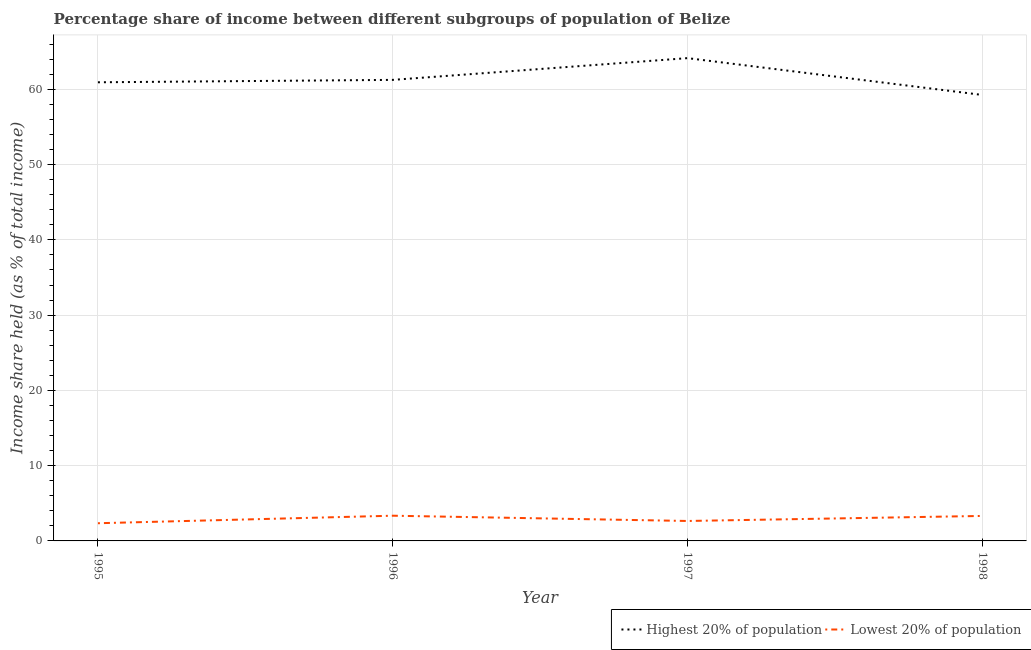Does the line corresponding to income share held by highest 20% of the population intersect with the line corresponding to income share held by lowest 20% of the population?
Your answer should be very brief. No. What is the income share held by highest 20% of the population in 1995?
Make the answer very short. 60.94. Across all years, what is the maximum income share held by lowest 20% of the population?
Provide a succinct answer. 3.35. Across all years, what is the minimum income share held by highest 20% of the population?
Offer a terse response. 59.26. In which year was the income share held by highest 20% of the population maximum?
Ensure brevity in your answer.  1997. In which year was the income share held by highest 20% of the population minimum?
Provide a succinct answer. 1998. What is the total income share held by highest 20% of the population in the graph?
Give a very brief answer. 245.61. What is the difference between the income share held by highest 20% of the population in 1995 and that in 1998?
Offer a very short reply. 1.68. What is the difference between the income share held by highest 20% of the population in 1997 and the income share held by lowest 20% of the population in 1995?
Provide a succinct answer. 61.8. What is the average income share held by highest 20% of the population per year?
Offer a very short reply. 61.4. In the year 1998, what is the difference between the income share held by highest 20% of the population and income share held by lowest 20% of the population?
Ensure brevity in your answer.  55.94. In how many years, is the income share held by lowest 20% of the population greater than 20 %?
Your response must be concise. 0. What is the ratio of the income share held by highest 20% of the population in 1995 to that in 1996?
Your response must be concise. 0.99. Is the income share held by lowest 20% of the population in 1996 less than that in 1998?
Provide a succinct answer. No. Is the difference between the income share held by highest 20% of the population in 1996 and 1998 greater than the difference between the income share held by lowest 20% of the population in 1996 and 1998?
Give a very brief answer. Yes. What is the difference between the highest and the second highest income share held by highest 20% of the population?
Your answer should be compact. 2.89. What is the difference between the highest and the lowest income share held by highest 20% of the population?
Offer a very short reply. 4.89. In how many years, is the income share held by highest 20% of the population greater than the average income share held by highest 20% of the population taken over all years?
Keep it short and to the point. 1. Does the income share held by lowest 20% of the population monotonically increase over the years?
Your answer should be compact. No. Is the income share held by highest 20% of the population strictly greater than the income share held by lowest 20% of the population over the years?
Offer a very short reply. Yes. Is the income share held by highest 20% of the population strictly less than the income share held by lowest 20% of the population over the years?
Offer a terse response. No. What is the difference between two consecutive major ticks on the Y-axis?
Give a very brief answer. 10. Does the graph contain grids?
Your answer should be compact. Yes. Where does the legend appear in the graph?
Provide a short and direct response. Bottom right. How are the legend labels stacked?
Provide a short and direct response. Horizontal. What is the title of the graph?
Offer a terse response. Percentage share of income between different subgroups of population of Belize. Does "All education staff compensation" appear as one of the legend labels in the graph?
Provide a short and direct response. No. What is the label or title of the X-axis?
Your answer should be compact. Year. What is the label or title of the Y-axis?
Make the answer very short. Income share held (as % of total income). What is the Income share held (as % of total income) in Highest 20% of population in 1995?
Your answer should be compact. 60.94. What is the Income share held (as % of total income) of Lowest 20% of population in 1995?
Ensure brevity in your answer.  2.35. What is the Income share held (as % of total income) in Highest 20% of population in 1996?
Make the answer very short. 61.26. What is the Income share held (as % of total income) of Lowest 20% of population in 1996?
Give a very brief answer. 3.35. What is the Income share held (as % of total income) in Highest 20% of population in 1997?
Offer a terse response. 64.15. What is the Income share held (as % of total income) in Lowest 20% of population in 1997?
Your answer should be very brief. 2.65. What is the Income share held (as % of total income) in Highest 20% of population in 1998?
Your answer should be compact. 59.26. What is the Income share held (as % of total income) in Lowest 20% of population in 1998?
Offer a terse response. 3.32. Across all years, what is the maximum Income share held (as % of total income) in Highest 20% of population?
Keep it short and to the point. 64.15. Across all years, what is the maximum Income share held (as % of total income) of Lowest 20% of population?
Provide a short and direct response. 3.35. Across all years, what is the minimum Income share held (as % of total income) of Highest 20% of population?
Provide a short and direct response. 59.26. Across all years, what is the minimum Income share held (as % of total income) of Lowest 20% of population?
Ensure brevity in your answer.  2.35. What is the total Income share held (as % of total income) of Highest 20% of population in the graph?
Your answer should be very brief. 245.61. What is the total Income share held (as % of total income) of Lowest 20% of population in the graph?
Offer a very short reply. 11.67. What is the difference between the Income share held (as % of total income) of Highest 20% of population in 1995 and that in 1996?
Provide a succinct answer. -0.32. What is the difference between the Income share held (as % of total income) of Highest 20% of population in 1995 and that in 1997?
Keep it short and to the point. -3.21. What is the difference between the Income share held (as % of total income) of Lowest 20% of population in 1995 and that in 1997?
Ensure brevity in your answer.  -0.3. What is the difference between the Income share held (as % of total income) in Highest 20% of population in 1995 and that in 1998?
Make the answer very short. 1.68. What is the difference between the Income share held (as % of total income) in Lowest 20% of population in 1995 and that in 1998?
Ensure brevity in your answer.  -0.97. What is the difference between the Income share held (as % of total income) of Highest 20% of population in 1996 and that in 1997?
Your answer should be very brief. -2.89. What is the difference between the Income share held (as % of total income) in Lowest 20% of population in 1996 and that in 1997?
Provide a succinct answer. 0.7. What is the difference between the Income share held (as % of total income) in Highest 20% of population in 1996 and that in 1998?
Your response must be concise. 2. What is the difference between the Income share held (as % of total income) in Highest 20% of population in 1997 and that in 1998?
Offer a very short reply. 4.89. What is the difference between the Income share held (as % of total income) in Lowest 20% of population in 1997 and that in 1998?
Provide a succinct answer. -0.67. What is the difference between the Income share held (as % of total income) of Highest 20% of population in 1995 and the Income share held (as % of total income) of Lowest 20% of population in 1996?
Provide a succinct answer. 57.59. What is the difference between the Income share held (as % of total income) of Highest 20% of population in 1995 and the Income share held (as % of total income) of Lowest 20% of population in 1997?
Provide a short and direct response. 58.29. What is the difference between the Income share held (as % of total income) of Highest 20% of population in 1995 and the Income share held (as % of total income) of Lowest 20% of population in 1998?
Make the answer very short. 57.62. What is the difference between the Income share held (as % of total income) of Highest 20% of population in 1996 and the Income share held (as % of total income) of Lowest 20% of population in 1997?
Keep it short and to the point. 58.61. What is the difference between the Income share held (as % of total income) of Highest 20% of population in 1996 and the Income share held (as % of total income) of Lowest 20% of population in 1998?
Offer a very short reply. 57.94. What is the difference between the Income share held (as % of total income) in Highest 20% of population in 1997 and the Income share held (as % of total income) in Lowest 20% of population in 1998?
Your answer should be very brief. 60.83. What is the average Income share held (as % of total income) of Highest 20% of population per year?
Give a very brief answer. 61.4. What is the average Income share held (as % of total income) in Lowest 20% of population per year?
Keep it short and to the point. 2.92. In the year 1995, what is the difference between the Income share held (as % of total income) in Highest 20% of population and Income share held (as % of total income) in Lowest 20% of population?
Keep it short and to the point. 58.59. In the year 1996, what is the difference between the Income share held (as % of total income) in Highest 20% of population and Income share held (as % of total income) in Lowest 20% of population?
Offer a terse response. 57.91. In the year 1997, what is the difference between the Income share held (as % of total income) in Highest 20% of population and Income share held (as % of total income) in Lowest 20% of population?
Your response must be concise. 61.5. In the year 1998, what is the difference between the Income share held (as % of total income) in Highest 20% of population and Income share held (as % of total income) in Lowest 20% of population?
Provide a succinct answer. 55.94. What is the ratio of the Income share held (as % of total income) in Lowest 20% of population in 1995 to that in 1996?
Your answer should be very brief. 0.7. What is the ratio of the Income share held (as % of total income) of Lowest 20% of population in 1995 to that in 1997?
Your response must be concise. 0.89. What is the ratio of the Income share held (as % of total income) of Highest 20% of population in 1995 to that in 1998?
Keep it short and to the point. 1.03. What is the ratio of the Income share held (as % of total income) of Lowest 20% of population in 1995 to that in 1998?
Ensure brevity in your answer.  0.71. What is the ratio of the Income share held (as % of total income) in Highest 20% of population in 1996 to that in 1997?
Offer a very short reply. 0.95. What is the ratio of the Income share held (as % of total income) in Lowest 20% of population in 1996 to that in 1997?
Keep it short and to the point. 1.26. What is the ratio of the Income share held (as % of total income) of Highest 20% of population in 1996 to that in 1998?
Offer a very short reply. 1.03. What is the ratio of the Income share held (as % of total income) of Lowest 20% of population in 1996 to that in 1998?
Offer a very short reply. 1.01. What is the ratio of the Income share held (as % of total income) in Highest 20% of population in 1997 to that in 1998?
Ensure brevity in your answer.  1.08. What is the ratio of the Income share held (as % of total income) in Lowest 20% of population in 1997 to that in 1998?
Your answer should be compact. 0.8. What is the difference between the highest and the second highest Income share held (as % of total income) of Highest 20% of population?
Make the answer very short. 2.89. What is the difference between the highest and the lowest Income share held (as % of total income) of Highest 20% of population?
Your answer should be compact. 4.89. What is the difference between the highest and the lowest Income share held (as % of total income) in Lowest 20% of population?
Your answer should be compact. 1. 